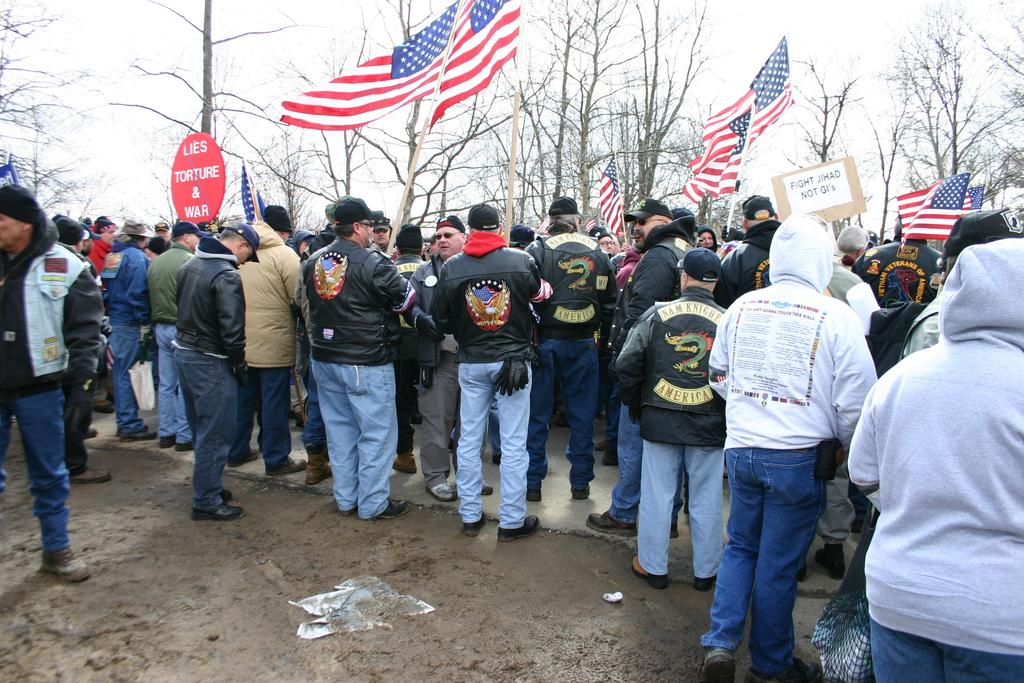What are the persons in the image doing? The persons in the image are standing on the ground. What are some of the persons holding in the image? Some of the persons are holding flags, hoardings, and bags. What can be seen in the background of the image? There are trees and the sky visible in the background of the image. Can you tell me how many boys are holding hands in the image? There is no mention of boys or hand-holding in the image; it features persons standing on the ground holding flags, hoardings, and bags. 